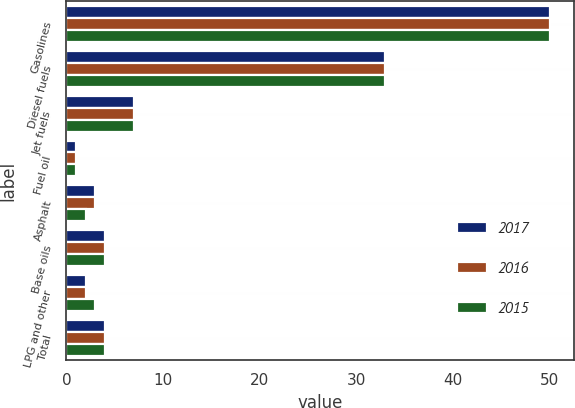Convert chart to OTSL. <chart><loc_0><loc_0><loc_500><loc_500><stacked_bar_chart><ecel><fcel>Gasolines<fcel>Diesel fuels<fcel>Jet fuels<fcel>Fuel oil<fcel>Asphalt<fcel>Base oils<fcel>LPG and other<fcel>Total<nl><fcel>2017<fcel>50<fcel>33<fcel>7<fcel>1<fcel>3<fcel>4<fcel>2<fcel>4<nl><fcel>2016<fcel>50<fcel>33<fcel>7<fcel>1<fcel>3<fcel>4<fcel>2<fcel>4<nl><fcel>2015<fcel>50<fcel>33<fcel>7<fcel>1<fcel>2<fcel>4<fcel>3<fcel>4<nl></chart> 